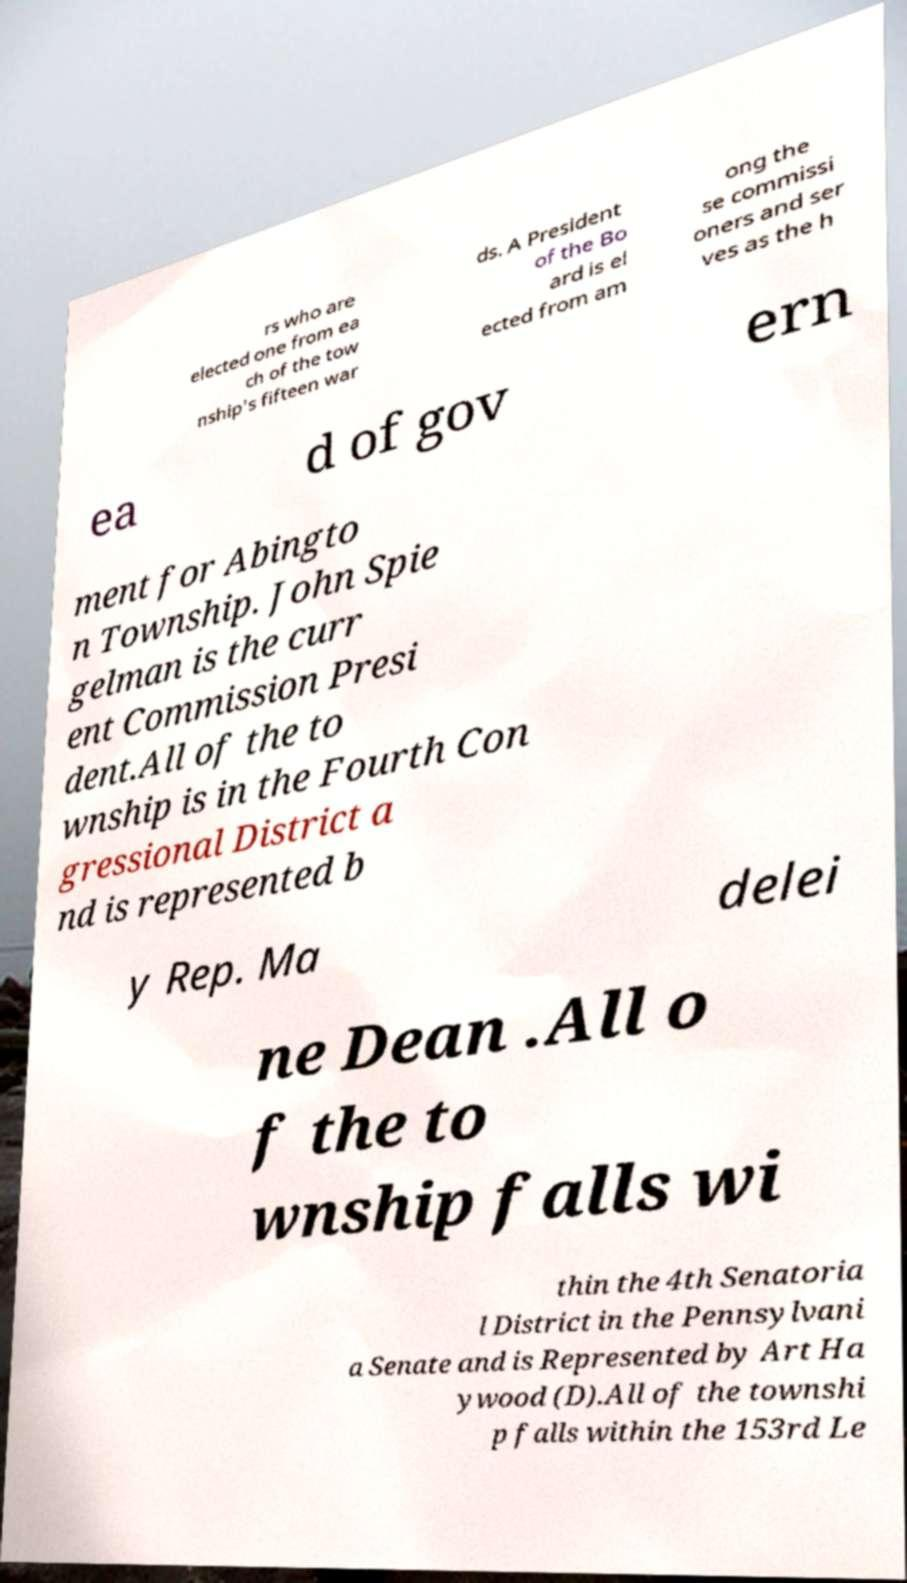There's text embedded in this image that I need extracted. Can you transcribe it verbatim? rs who are elected one from ea ch of the tow nship's fifteen war ds. A President of the Bo ard is el ected from am ong the se commissi oners and ser ves as the h ea d of gov ern ment for Abingto n Township. John Spie gelman is the curr ent Commission Presi dent.All of the to wnship is in the Fourth Con gressional District a nd is represented b y Rep. Ma delei ne Dean .All o f the to wnship falls wi thin the 4th Senatoria l District in the Pennsylvani a Senate and is Represented by Art Ha ywood (D).All of the townshi p falls within the 153rd Le 